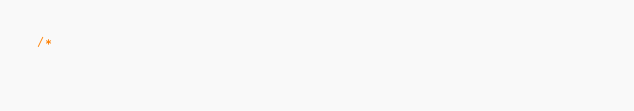<code> <loc_0><loc_0><loc_500><loc_500><_C_>/*</code> 